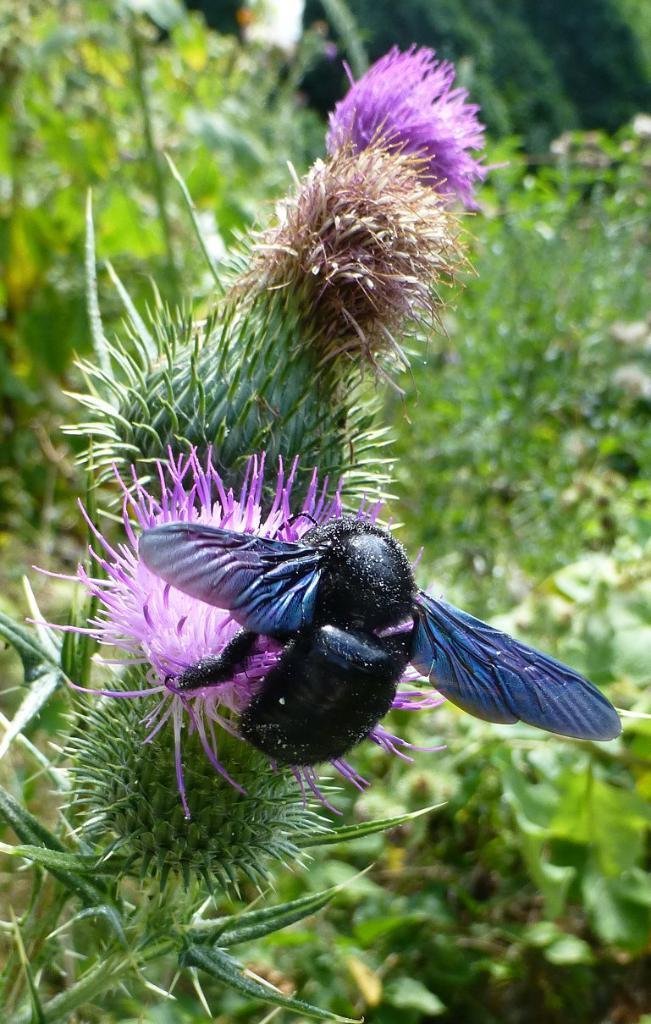Can you describe this image briefly? In the foreground of the picture I can see an insect on the spear thistle plant. In the background, I can see the plants. 